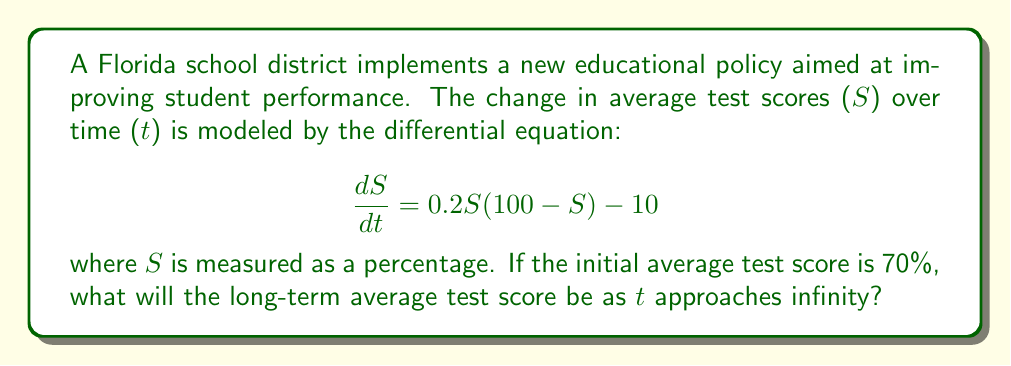Can you answer this question? To find the long-term average test score, we need to determine the stable equilibrium point of the given differential equation. This involves the following steps:

1) First, we set $\frac{dS}{dt} = 0$ to find the equilibrium points:

   $$0 = 0.2S(100 - S) - 10$$

2) Expand the equation:

   $$0 = 20S - 0.2S^2 - 10$$

3) Rearrange to standard quadratic form:

   $$0.2S^2 - 20S + 10 = 0$$

4) Solve using the quadratic formula: $S = \frac{-b \pm \sqrt{b^2 - 4ac}}{2a}$

   Where $a = 0.2$, $b = -20$, and $c = 10$

   $$S = \frac{20 \pm \sqrt{400 - 8}}{0.4} = \frac{20 \pm \sqrt{392}}{0.4}$$

5) This gives us two equilibrium points:

   $$S_1 \approx 95.8\%$$
   $$S_2 \approx 4.2\%$$

6) To determine which equilibrium is stable, we evaluate $\frac{d}{dS}(\frac{dS}{dt})$ at each point:

   $$\frac{d}{dS}(\frac{dS}{dt}) = 0.2(100 - S) - 0.2S = 20 - 0.4S$$

   At $S_1 \approx 95.8$: $20 - 0.4(95.8) \approx -18.32 < 0$ (stable)
   At $S_2 \approx 4.2$: $20 - 0.4(4.2) \approx 18.32 > 0$ (unstable)

7) Since the initial score (70%) is closer to the stable equilibrium, the long-term average will approach $S_1 \approx 95.8\%$.
Answer: 95.8% 